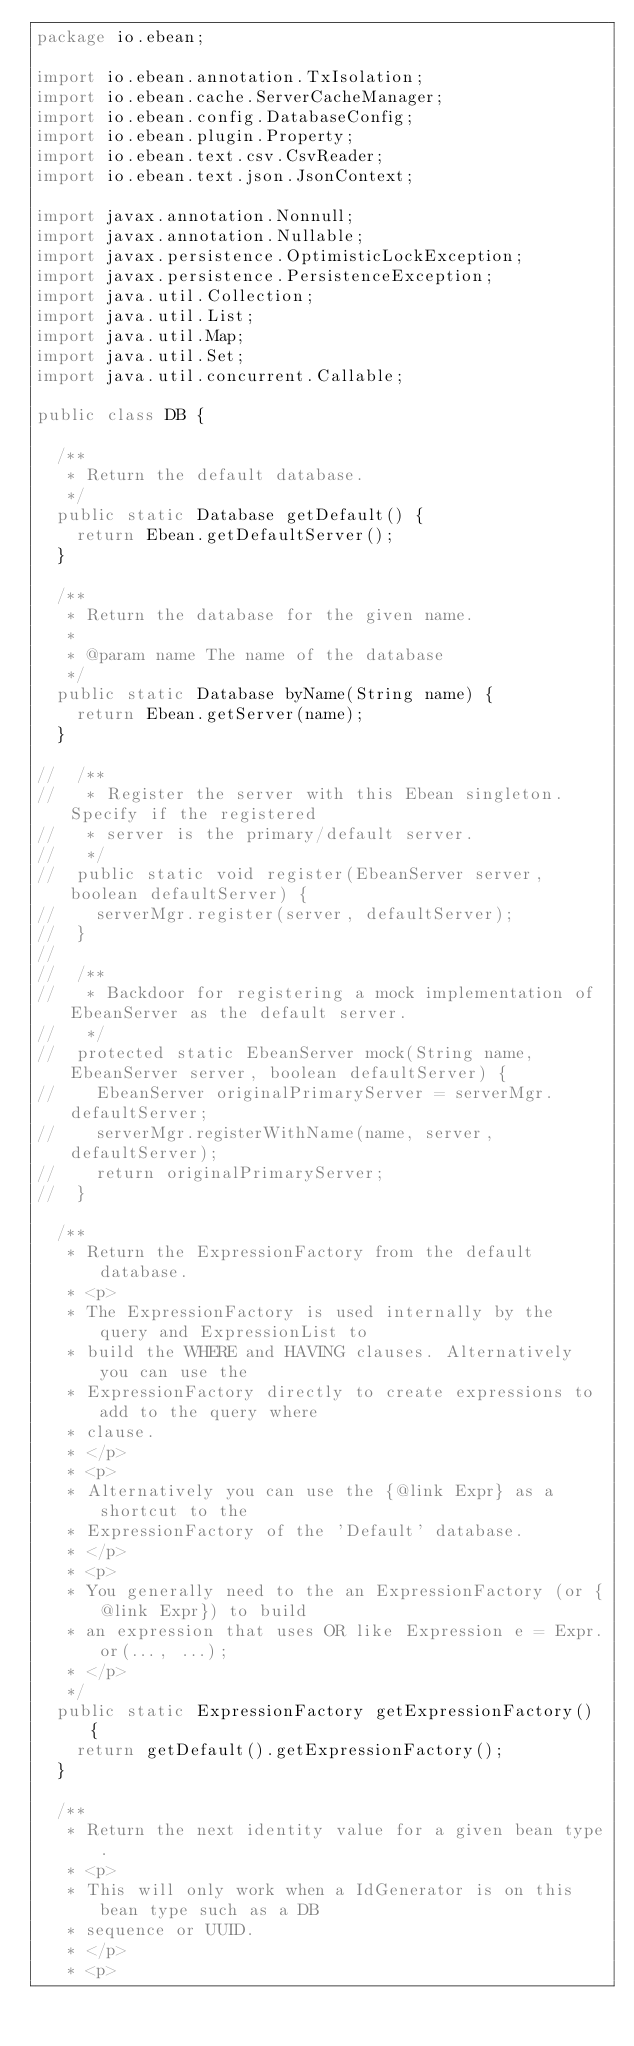Convert code to text. <code><loc_0><loc_0><loc_500><loc_500><_Java_>package io.ebean;

import io.ebean.annotation.TxIsolation;
import io.ebean.cache.ServerCacheManager;
import io.ebean.config.DatabaseConfig;
import io.ebean.plugin.Property;
import io.ebean.text.csv.CsvReader;
import io.ebean.text.json.JsonContext;

import javax.annotation.Nonnull;
import javax.annotation.Nullable;
import javax.persistence.OptimisticLockException;
import javax.persistence.PersistenceException;
import java.util.Collection;
import java.util.List;
import java.util.Map;
import java.util.Set;
import java.util.concurrent.Callable;

public class DB {

  /**
   * Return the default database.
   */
  public static Database getDefault() {
    return Ebean.getDefaultServer();
  }

  /**
   * Return the database for the given name.
   *
   * @param name The name of the database
   */
  public static Database byName(String name) {
    return Ebean.getServer(name);
  }

//  /**
//   * Register the server with this Ebean singleton. Specify if the registered
//   * server is the primary/default server.
//   */
//  public static void register(EbeanServer server, boolean defaultServer) {
//    serverMgr.register(server, defaultServer);
//  }
//
//  /**
//   * Backdoor for registering a mock implementation of EbeanServer as the default server.
//   */
//  protected static EbeanServer mock(String name, EbeanServer server, boolean defaultServer) {
//    EbeanServer originalPrimaryServer = serverMgr.defaultServer;
//    serverMgr.registerWithName(name, server, defaultServer);
//    return originalPrimaryServer;
//  }

  /**
   * Return the ExpressionFactory from the default database.
   * <p>
   * The ExpressionFactory is used internally by the query and ExpressionList to
   * build the WHERE and HAVING clauses. Alternatively you can use the
   * ExpressionFactory directly to create expressions to add to the query where
   * clause.
   * </p>
   * <p>
   * Alternatively you can use the {@link Expr} as a shortcut to the
   * ExpressionFactory of the 'Default' database.
   * </p>
   * <p>
   * You generally need to the an ExpressionFactory (or {@link Expr}) to build
   * an expression that uses OR like Expression e = Expr.or(..., ...);
   * </p>
   */
  public static ExpressionFactory getExpressionFactory() {
    return getDefault().getExpressionFactory();
  }

  /**
   * Return the next identity value for a given bean type.
   * <p>
   * This will only work when a IdGenerator is on this bean type such as a DB
   * sequence or UUID.
   * </p>
   * <p></code> 